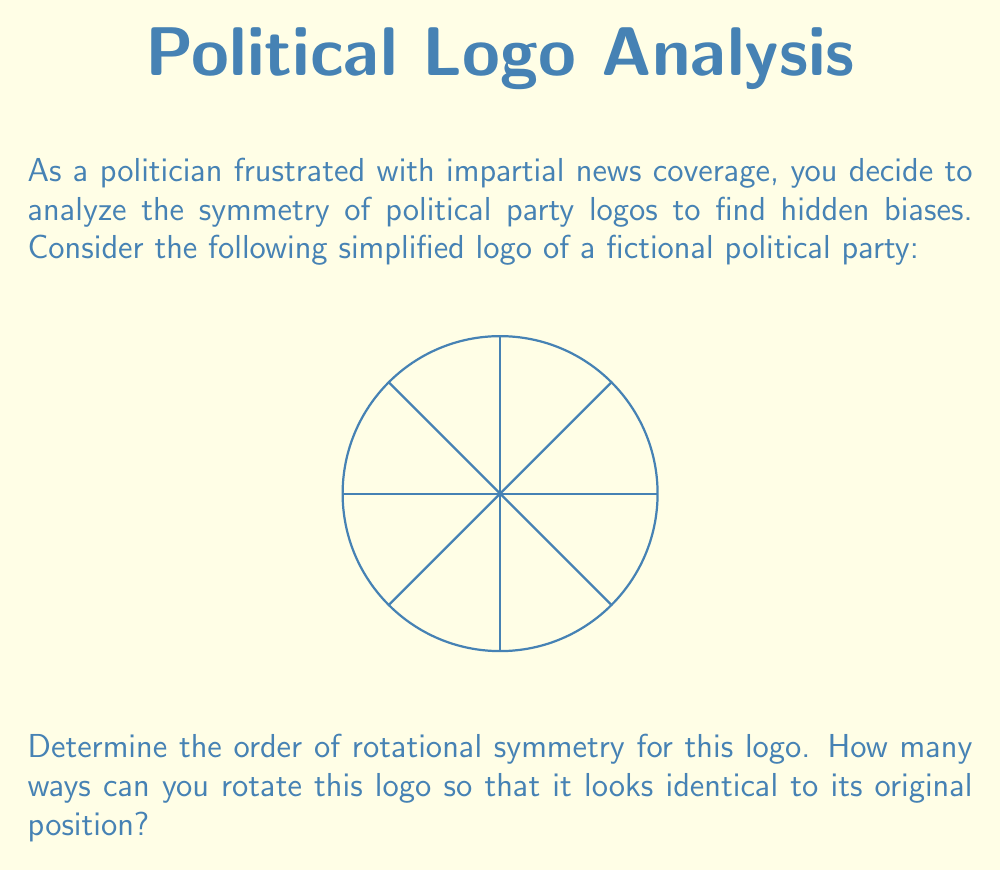What is the answer to this math problem? To determine the order of rotational symmetry, we need to analyze how many distinct rotations bring the logo back to its original appearance. Let's approach this step-by-step:

1) First, observe the logo carefully. It consists of a circle with four lines intersecting at the center, forming 8 equal sectors.

2) A full rotation of 360° always brings any shape back to its original position. We need to find how many smaller rotations also work.

3) Let's consider the possible rotations:
   - 45° rotation: This aligns one line with where another was, changing the appearance.
   - 90° rotation: This brings the logo back to its original appearance.
   - 180° rotation: This also brings the logo back to its original appearance.
   - 270° rotation: This is equivalent to a 90° rotation in the opposite direction.

4) We can express this mathematically:
   $$\text{Order of symmetry} = \frac{360°}{\text{Smallest rotation that returns to original}}$$

5) The smallest rotation that returns the logo to its original position is 90°.

6) Therefore:
   $$\text{Order of symmetry} = \frac{360°}{90°} = 4$$

This means there are 4 ways to rotate the logo so that it looks identical to its original position: 0° (original), 90°, 180°, and 270°.
Answer: 4 